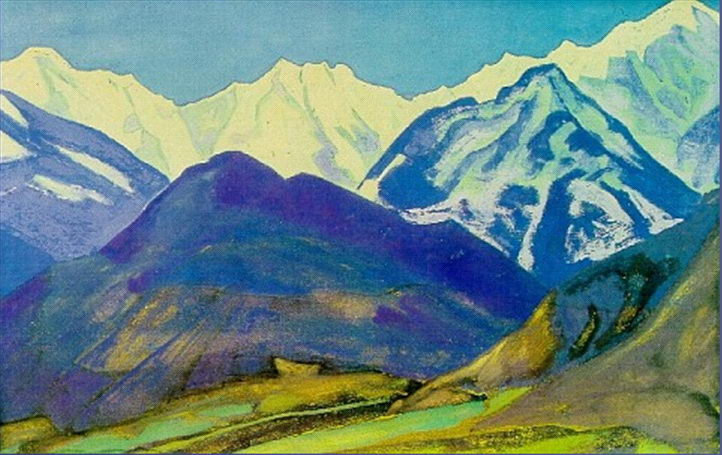What season is depicted in the image? The painting likely depicts a late spring or early summer season. The vibrant green valley and the presence of snow on the mountain peaks suggest a time when the lowlands are thriving with plant life while higher altitudes still retain their winter snow. 